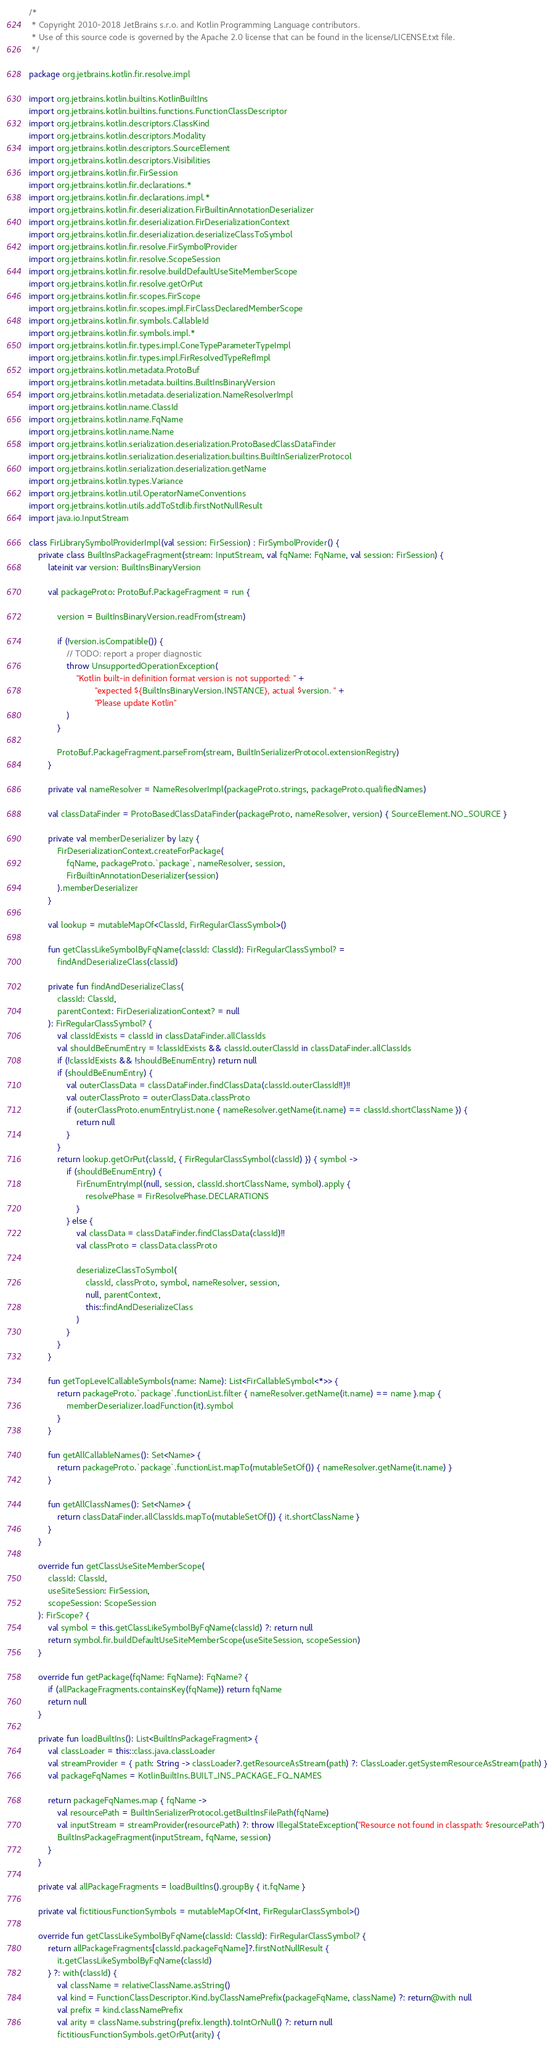Convert code to text. <code><loc_0><loc_0><loc_500><loc_500><_Kotlin_>/*
 * Copyright 2010-2018 JetBrains s.r.o. and Kotlin Programming Language contributors.
 * Use of this source code is governed by the Apache 2.0 license that can be found in the license/LICENSE.txt file.
 */

package org.jetbrains.kotlin.fir.resolve.impl

import org.jetbrains.kotlin.builtins.KotlinBuiltIns
import org.jetbrains.kotlin.builtins.functions.FunctionClassDescriptor
import org.jetbrains.kotlin.descriptors.ClassKind
import org.jetbrains.kotlin.descriptors.Modality
import org.jetbrains.kotlin.descriptors.SourceElement
import org.jetbrains.kotlin.descriptors.Visibilities
import org.jetbrains.kotlin.fir.FirSession
import org.jetbrains.kotlin.fir.declarations.*
import org.jetbrains.kotlin.fir.declarations.impl.*
import org.jetbrains.kotlin.fir.deserialization.FirBuiltinAnnotationDeserializer
import org.jetbrains.kotlin.fir.deserialization.FirDeserializationContext
import org.jetbrains.kotlin.fir.deserialization.deserializeClassToSymbol
import org.jetbrains.kotlin.fir.resolve.FirSymbolProvider
import org.jetbrains.kotlin.fir.resolve.ScopeSession
import org.jetbrains.kotlin.fir.resolve.buildDefaultUseSiteMemberScope
import org.jetbrains.kotlin.fir.resolve.getOrPut
import org.jetbrains.kotlin.fir.scopes.FirScope
import org.jetbrains.kotlin.fir.scopes.impl.FirClassDeclaredMemberScope
import org.jetbrains.kotlin.fir.symbols.CallableId
import org.jetbrains.kotlin.fir.symbols.impl.*
import org.jetbrains.kotlin.fir.types.impl.ConeTypeParameterTypeImpl
import org.jetbrains.kotlin.fir.types.impl.FirResolvedTypeRefImpl
import org.jetbrains.kotlin.metadata.ProtoBuf
import org.jetbrains.kotlin.metadata.builtins.BuiltInsBinaryVersion
import org.jetbrains.kotlin.metadata.deserialization.NameResolverImpl
import org.jetbrains.kotlin.name.ClassId
import org.jetbrains.kotlin.name.FqName
import org.jetbrains.kotlin.name.Name
import org.jetbrains.kotlin.serialization.deserialization.ProtoBasedClassDataFinder
import org.jetbrains.kotlin.serialization.deserialization.builtins.BuiltInSerializerProtocol
import org.jetbrains.kotlin.serialization.deserialization.getName
import org.jetbrains.kotlin.types.Variance
import org.jetbrains.kotlin.util.OperatorNameConventions
import org.jetbrains.kotlin.utils.addToStdlib.firstNotNullResult
import java.io.InputStream

class FirLibrarySymbolProviderImpl(val session: FirSession) : FirSymbolProvider() {
    private class BuiltInsPackageFragment(stream: InputStream, val fqName: FqName, val session: FirSession) {
        lateinit var version: BuiltInsBinaryVersion

        val packageProto: ProtoBuf.PackageFragment = run {

            version = BuiltInsBinaryVersion.readFrom(stream)

            if (!version.isCompatible()) {
                // TODO: report a proper diagnostic
                throw UnsupportedOperationException(
                    "Kotlin built-in definition format version is not supported: " +
                            "expected ${BuiltInsBinaryVersion.INSTANCE}, actual $version. " +
                            "Please update Kotlin"
                )
            }

            ProtoBuf.PackageFragment.parseFrom(stream, BuiltInSerializerProtocol.extensionRegistry)
        }

        private val nameResolver = NameResolverImpl(packageProto.strings, packageProto.qualifiedNames)

        val classDataFinder = ProtoBasedClassDataFinder(packageProto, nameResolver, version) { SourceElement.NO_SOURCE }

        private val memberDeserializer by lazy {
            FirDeserializationContext.createForPackage(
                fqName, packageProto.`package`, nameResolver, session,
                FirBuiltinAnnotationDeserializer(session)
            ).memberDeserializer
        }

        val lookup = mutableMapOf<ClassId, FirRegularClassSymbol>()

        fun getClassLikeSymbolByFqName(classId: ClassId): FirRegularClassSymbol? =
            findAndDeserializeClass(classId)

        private fun findAndDeserializeClass(
            classId: ClassId,
            parentContext: FirDeserializationContext? = null
        ): FirRegularClassSymbol? {
            val classIdExists = classId in classDataFinder.allClassIds
            val shouldBeEnumEntry = !classIdExists && classId.outerClassId in classDataFinder.allClassIds
            if (!classIdExists && !shouldBeEnumEntry) return null
            if (shouldBeEnumEntry) {
                val outerClassData = classDataFinder.findClassData(classId.outerClassId!!)!!
                val outerClassProto = outerClassData.classProto
                if (outerClassProto.enumEntryList.none { nameResolver.getName(it.name) == classId.shortClassName }) {
                    return null
                }
            }
            return lookup.getOrPut(classId, { FirRegularClassSymbol(classId) }) { symbol ->
                if (shouldBeEnumEntry) {
                    FirEnumEntryImpl(null, session, classId.shortClassName, symbol).apply {
                        resolvePhase = FirResolvePhase.DECLARATIONS
                    }
                } else {
                    val classData = classDataFinder.findClassData(classId)!!
                    val classProto = classData.classProto

                    deserializeClassToSymbol(
                        classId, classProto, symbol, nameResolver, session,
                        null, parentContext,
                        this::findAndDeserializeClass
                    )
                }
            }
        }

        fun getTopLevelCallableSymbols(name: Name): List<FirCallableSymbol<*>> {
            return packageProto.`package`.functionList.filter { nameResolver.getName(it.name) == name }.map {
                memberDeserializer.loadFunction(it).symbol
            }
        }

        fun getAllCallableNames(): Set<Name> {
            return packageProto.`package`.functionList.mapTo(mutableSetOf()) { nameResolver.getName(it.name) }
        }

        fun getAllClassNames(): Set<Name> {
            return classDataFinder.allClassIds.mapTo(mutableSetOf()) { it.shortClassName }
        }
    }

    override fun getClassUseSiteMemberScope(
        classId: ClassId,
        useSiteSession: FirSession,
        scopeSession: ScopeSession
    ): FirScope? {
        val symbol = this.getClassLikeSymbolByFqName(classId) ?: return null
        return symbol.fir.buildDefaultUseSiteMemberScope(useSiteSession, scopeSession)
    }

    override fun getPackage(fqName: FqName): FqName? {
        if (allPackageFragments.containsKey(fqName)) return fqName
        return null
    }

    private fun loadBuiltIns(): List<BuiltInsPackageFragment> {
        val classLoader = this::class.java.classLoader
        val streamProvider = { path: String -> classLoader?.getResourceAsStream(path) ?: ClassLoader.getSystemResourceAsStream(path) }
        val packageFqNames = KotlinBuiltIns.BUILT_INS_PACKAGE_FQ_NAMES

        return packageFqNames.map { fqName ->
            val resourcePath = BuiltInSerializerProtocol.getBuiltInsFilePath(fqName)
            val inputStream = streamProvider(resourcePath) ?: throw IllegalStateException("Resource not found in classpath: $resourcePath")
            BuiltInsPackageFragment(inputStream, fqName, session)
        }
    }

    private val allPackageFragments = loadBuiltIns().groupBy { it.fqName }

    private val fictitiousFunctionSymbols = mutableMapOf<Int, FirRegularClassSymbol>()

    override fun getClassLikeSymbolByFqName(classId: ClassId): FirRegularClassSymbol? {
        return allPackageFragments[classId.packageFqName]?.firstNotNullResult {
            it.getClassLikeSymbolByFqName(classId)
        } ?: with(classId) {
            val className = relativeClassName.asString()
            val kind = FunctionClassDescriptor.Kind.byClassNamePrefix(packageFqName, className) ?: return@with null
            val prefix = kind.classNamePrefix
            val arity = className.substring(prefix.length).toIntOrNull() ?: return null
            fictitiousFunctionSymbols.getOrPut(arity) {</code> 